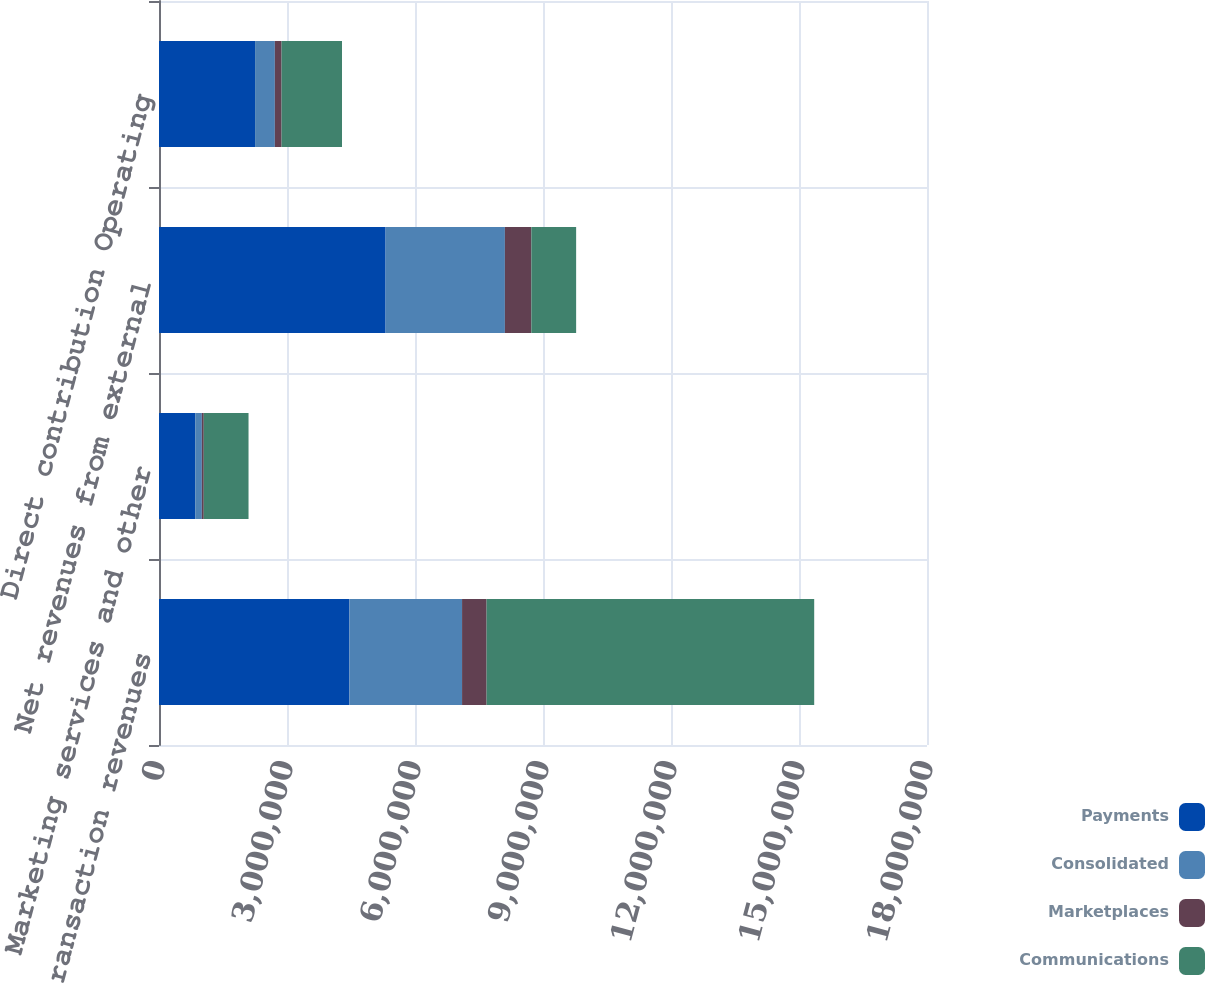Convert chart. <chart><loc_0><loc_0><loc_500><loc_500><stacked_bar_chart><ecel><fcel>Net transaction revenues<fcel>Marketing services and other<fcel>Net revenues from external<fcel>Direct contribution Operating<nl><fcel>Payments<fcel>4.46184e+06<fcel>849169<fcel>5.31101e+06<fcel>2.25192e+06<nl><fcel>Consolidated<fcel>2.64119e+06<fcel>154751<fcel>2.79594e+06<fcel>463382<nl><fcel>Marketplaces<fcel>575096<fcel>45307<fcel>620403<fcel>157702<nl><fcel>Communications<fcel>7.67814e+06<fcel>1.04923e+06<fcel>1.04923e+06<fcel>1.41624e+06<nl></chart> 